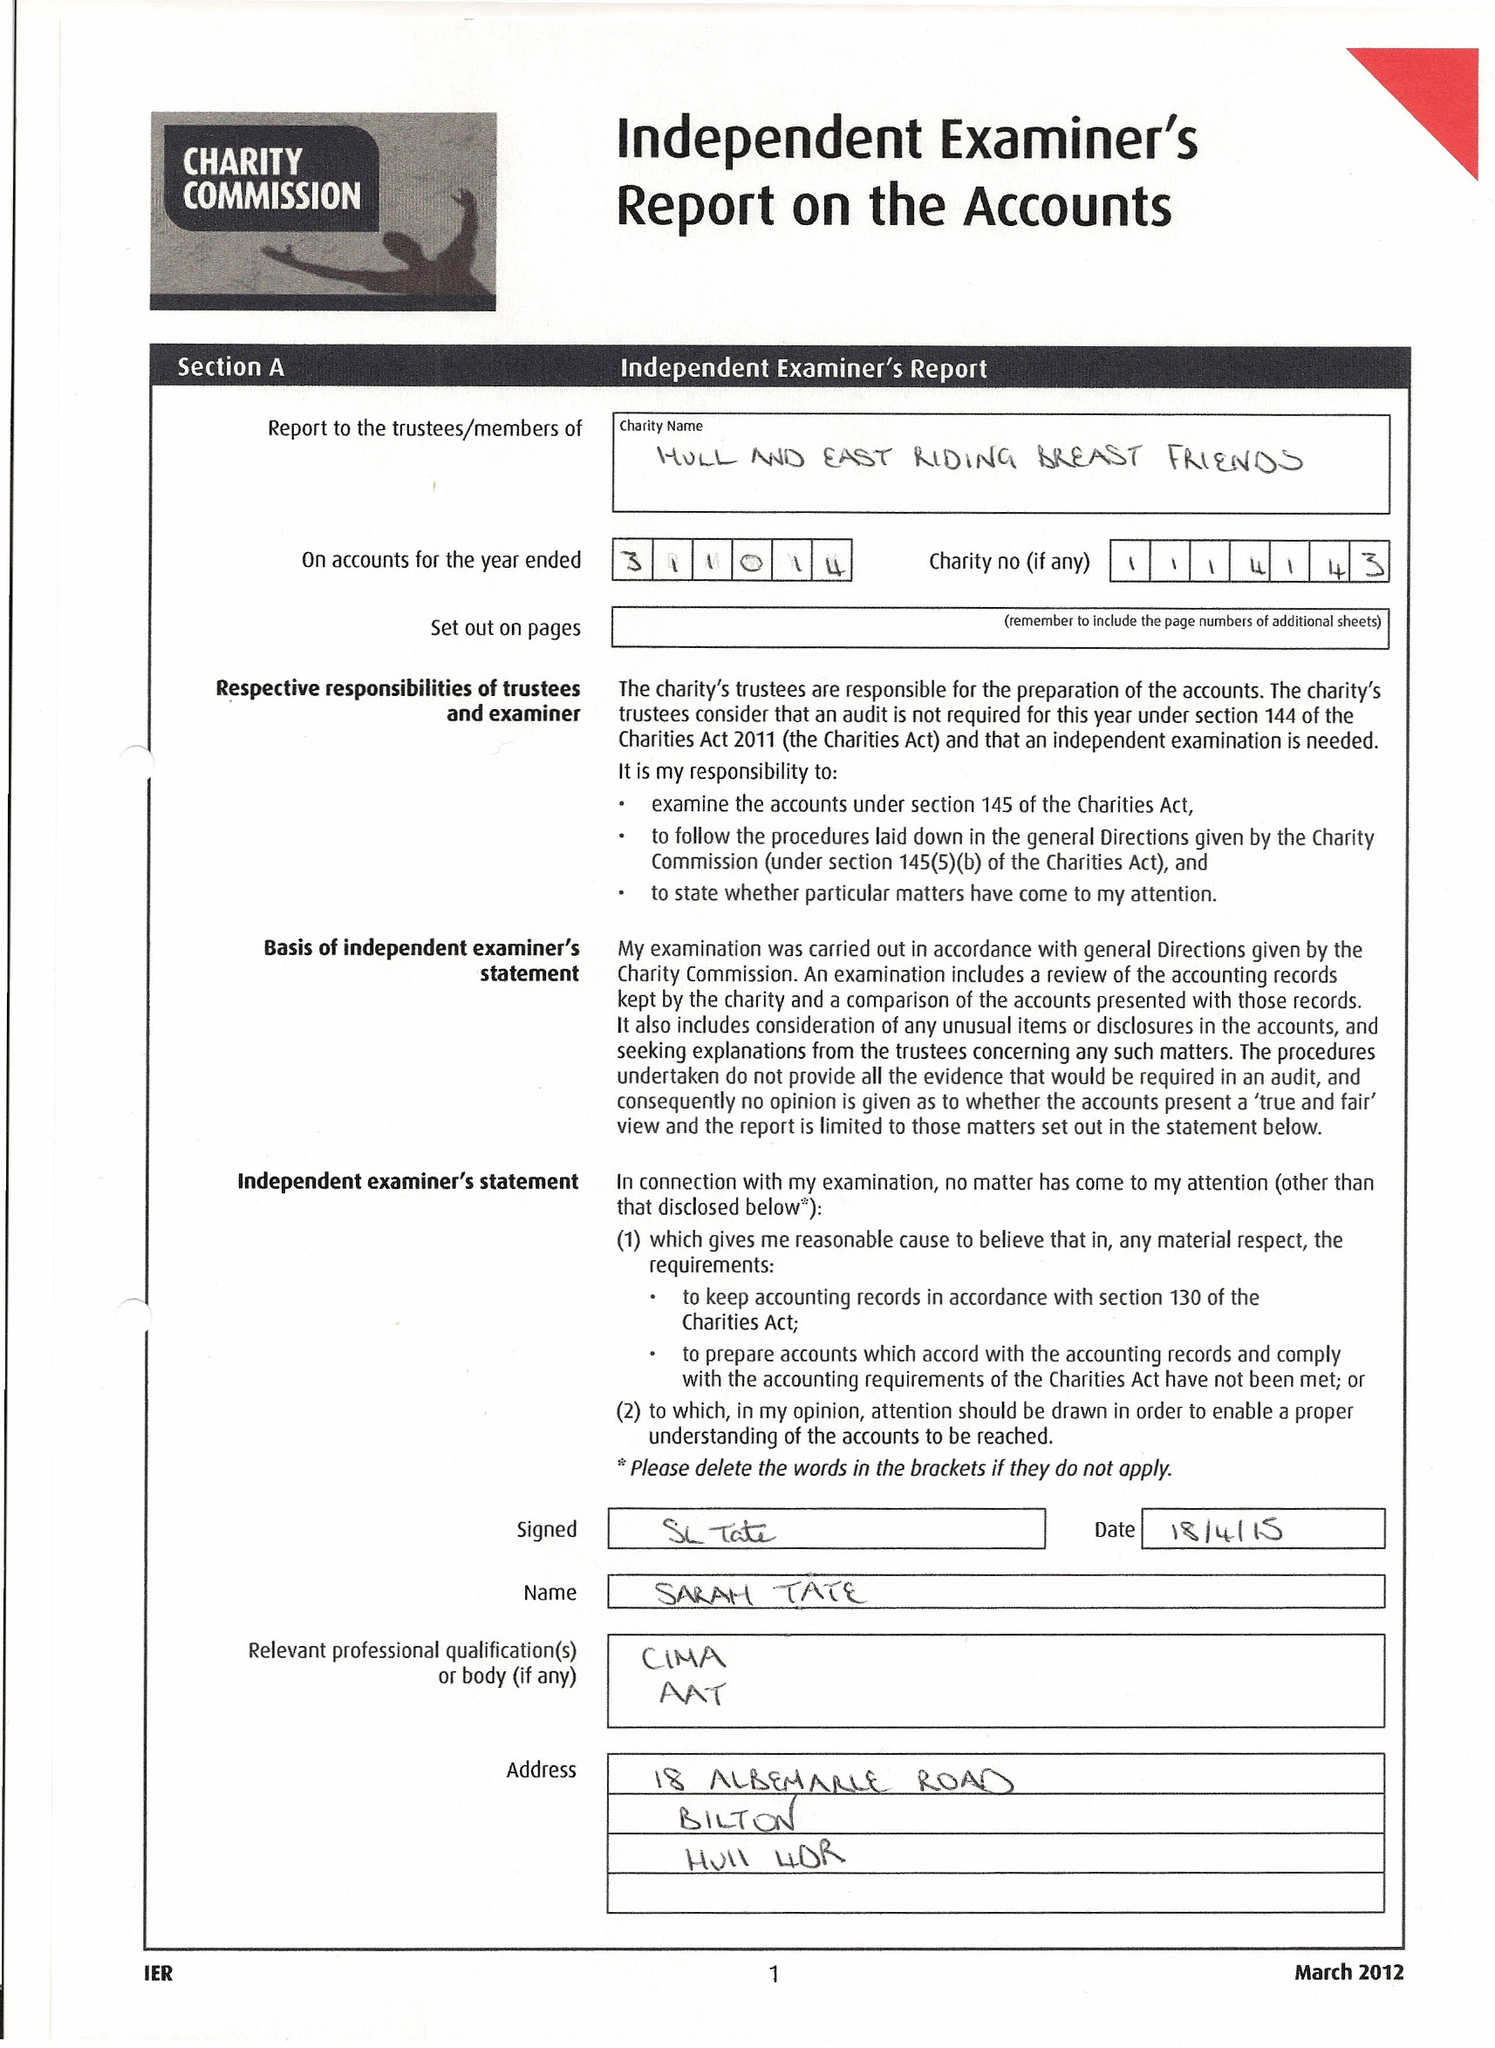What is the value for the address__street_line?
Answer the question using a single word or phrase. WALKER STREET 